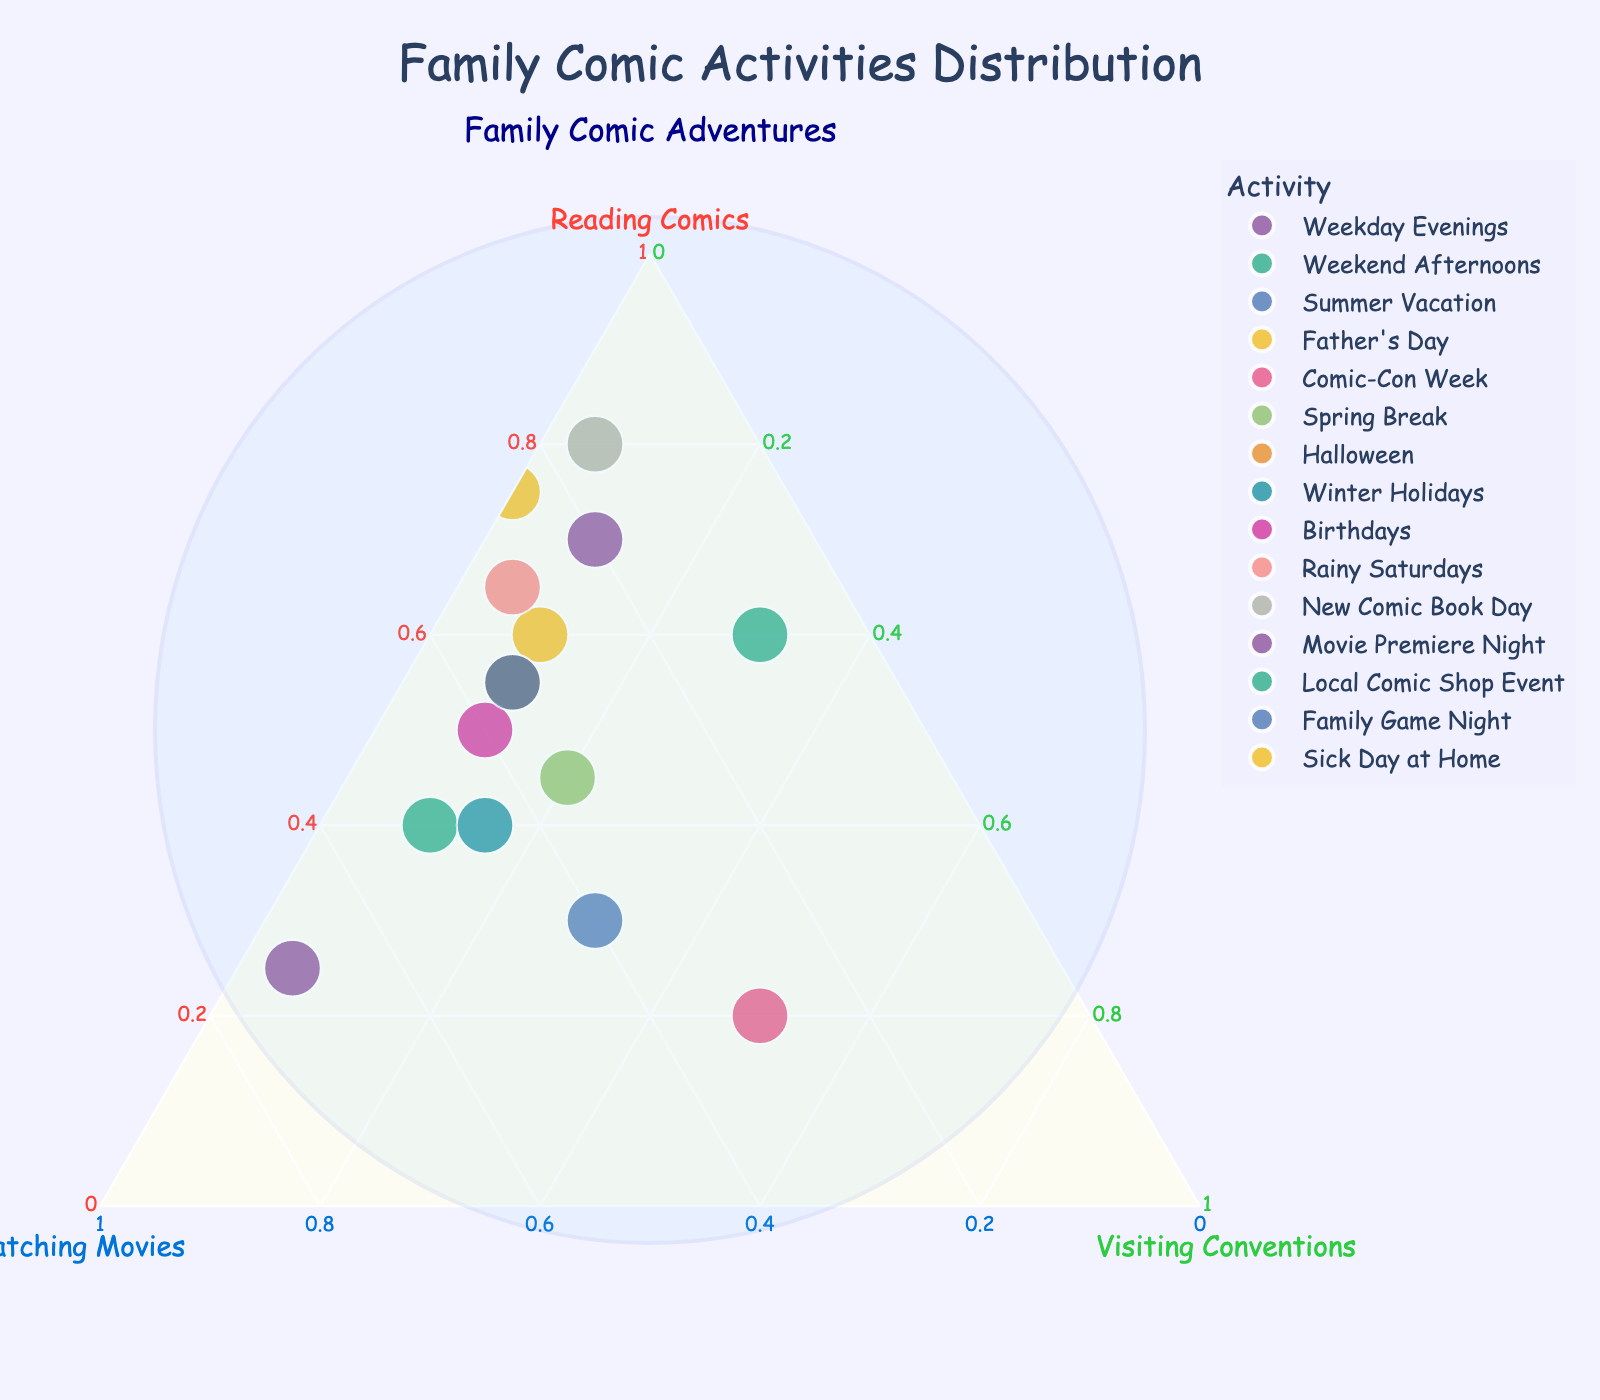How many activities are represented in the plot? Count the number of distinct data points or activities shown on the plot.
Answer: 15 What is the title of the plot? Look at the top of the figure for the title text.
Answer: Family Comic Activities Distribution Which activity has the highest proportion of "Reading Comics"? Identify the data point located closest to the "Reading Comics" vertex.
Answer: New Comic Book Day Which activity spends 20% on "Visiting Conventions"? Find the activity whose corresponding point lies on the 20% line from the "Visiting Conventions" axis.
Answer: Spring Break On which day is the family least likely to spend time "Watching Movies"? Identify the activity whose point is farthest from the "Watching Movies" vertex.
Answer: Sick Day at Home What's the sum of the proportions for "Reading Comics" and "Watching Movies" during Summer Vacation? Add the given proportions for "Reading Comics" and "Watching Movies" for the "Summer Vacation" activity.
Answer: 70% Which two activities have the exact same percentage for "Visiting Conventions"? Find two data points that lie on the same level line from the "Visiting Conventions" vertex.
Answer: Local Comic Shop Event and Summer Vacation Is there any activity where the time spent is equally distributed between two activities? Look for a data point lying on the line that splits any two of the axes equally.
Answer: Weekend Afternoons (Reading Comics 40% and Watching Movies 50%) Compare the percentage of "Reading Comics" during Weekday Evenings and Sick Day at Home. Which one has a higher percentage? Check the positions of these points relative to the "Reading Comics" vertex.
Answer: Sick Day at Home What’s the median proportion of "Reading Comics" across all activities? Rank all the activities by their "Reading Comics" proportions and find the middle value. The values are: 70%, 40%, 30%, 60%, 20%, 45%, 55%, 40%, 50%, 65%, 80%, 25%, 60%, 55%, 75%.
Answer: 55% 